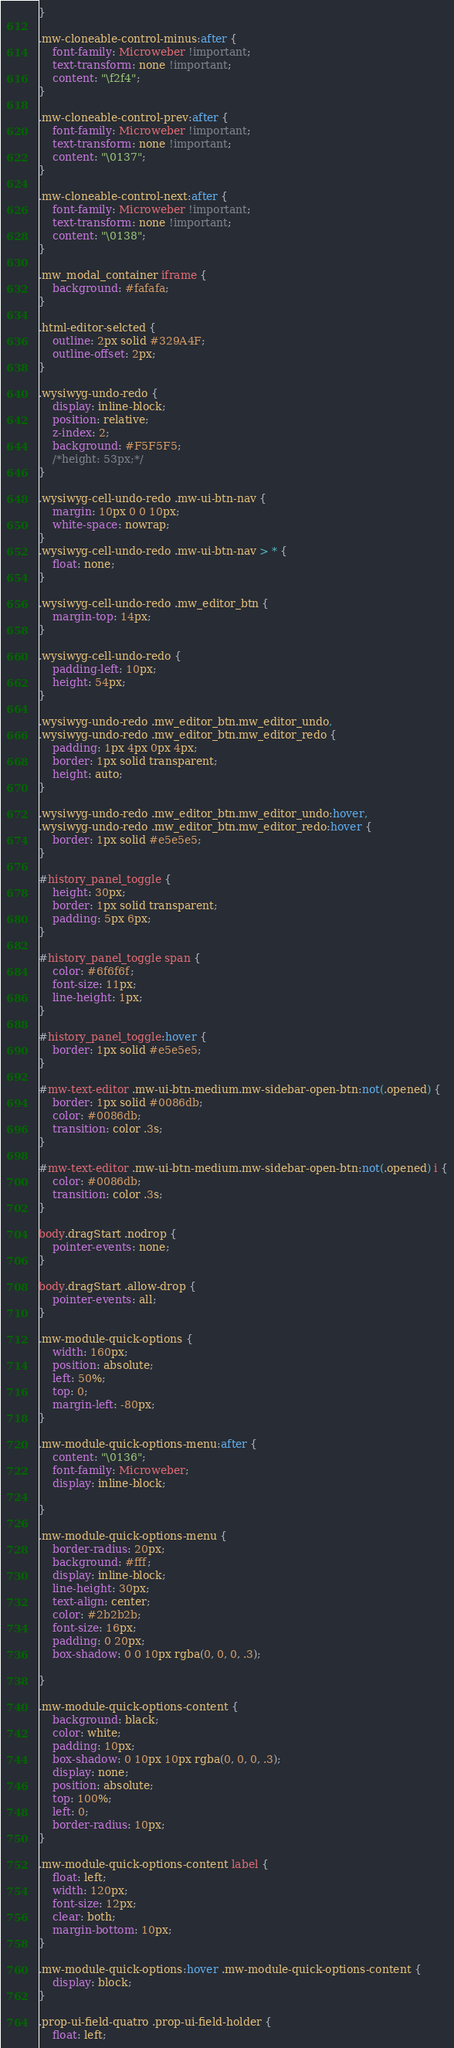<code> <loc_0><loc_0><loc_500><loc_500><_CSS_>}

.mw-cloneable-control-minus:after {
    font-family: Microweber !important;
    text-transform: none !important;
    content: "\f2f4";
}

.mw-cloneable-control-prev:after {
    font-family: Microweber !important;
    text-transform: none !important;
    content: "\0137";
}

.mw-cloneable-control-next:after {
    font-family: Microweber !important;
    text-transform: none !important;
    content: "\0138";
}

.mw_modal_container iframe {
    background: #fafafa;
}

.html-editor-selcted {
    outline: 2px solid #329A4F;
    outline-offset: 2px;
}

.wysiwyg-undo-redo {
    display: inline-block;
    position: relative;
    z-index: 2;
    background: #F5F5F5;
    /*height: 53px;*/
}

.wysiwyg-cell-undo-redo .mw-ui-btn-nav {
    margin: 10px 0 0 10px;
    white-space: nowrap;
}
.wysiwyg-cell-undo-redo .mw-ui-btn-nav > * {
    float: none;
}

.wysiwyg-cell-undo-redo .mw_editor_btn {
    margin-top: 14px;
}

.wysiwyg-cell-undo-redo {
    padding-left: 10px;
    height: 54px;
}

.wysiwyg-undo-redo .mw_editor_btn.mw_editor_undo,
.wysiwyg-undo-redo .mw_editor_btn.mw_editor_redo {
    padding: 1px 4px 0px 4px;
    border: 1px solid transparent;
    height: auto;
}

.wysiwyg-undo-redo .mw_editor_btn.mw_editor_undo:hover,
.wysiwyg-undo-redo .mw_editor_btn.mw_editor_redo:hover {
    border: 1px solid #e5e5e5;
}

#history_panel_toggle {
    height: 30px;
    border: 1px solid transparent;
    padding: 5px 6px;
}

#history_panel_toggle span {
    color: #6f6f6f;
    font-size: 11px;
    line-height: 1px;
}

#history_panel_toggle:hover {
    border: 1px solid #e5e5e5;
}

#mw-text-editor .mw-ui-btn-medium.mw-sidebar-open-btn:not(.opened) {
    border: 1px solid #0086db;
    color: #0086db;
    transition: color .3s;
}

#mw-text-editor .mw-ui-btn-medium.mw-sidebar-open-btn:not(.opened) i {
    color: #0086db;
    transition: color .3s;
}

body.dragStart .nodrop {
    pointer-events: none;
}

body.dragStart .allow-drop {
    pointer-events: all;
}

.mw-module-quick-options {
    width: 160px;
    position: absolute;
    left: 50%;
    top: 0;
    margin-left: -80px;
}

.mw-module-quick-options-menu:after {
    content: "\0136";
    font-family: Microweber;
    display: inline-block;

}

.mw-module-quick-options-menu {
    border-radius: 20px;
    background: #fff;
    display: inline-block;
    line-height: 30px;
    text-align: center;
    color: #2b2b2b;
    font-size: 16px;
    padding: 0 20px;
    box-shadow: 0 0 10px rgba(0, 0, 0, .3);

}

.mw-module-quick-options-content {
    background: black;
    color: white;
    padding: 10px;
    box-shadow: 0 10px 10px rgba(0, 0, 0, .3);
    display: none;
    position: absolute;
    top: 100%;
    left: 0;
    border-radius: 10px;
}

.mw-module-quick-options-content label {
    float: left;
    width: 120px;
    font-size: 12px;
    clear: both;
    margin-bottom: 10px;
}

.mw-module-quick-options:hover .mw-module-quick-options-content {
    display: block;
}

.prop-ui-field-quatro .prop-ui-field-holder {
    float: left;</code> 